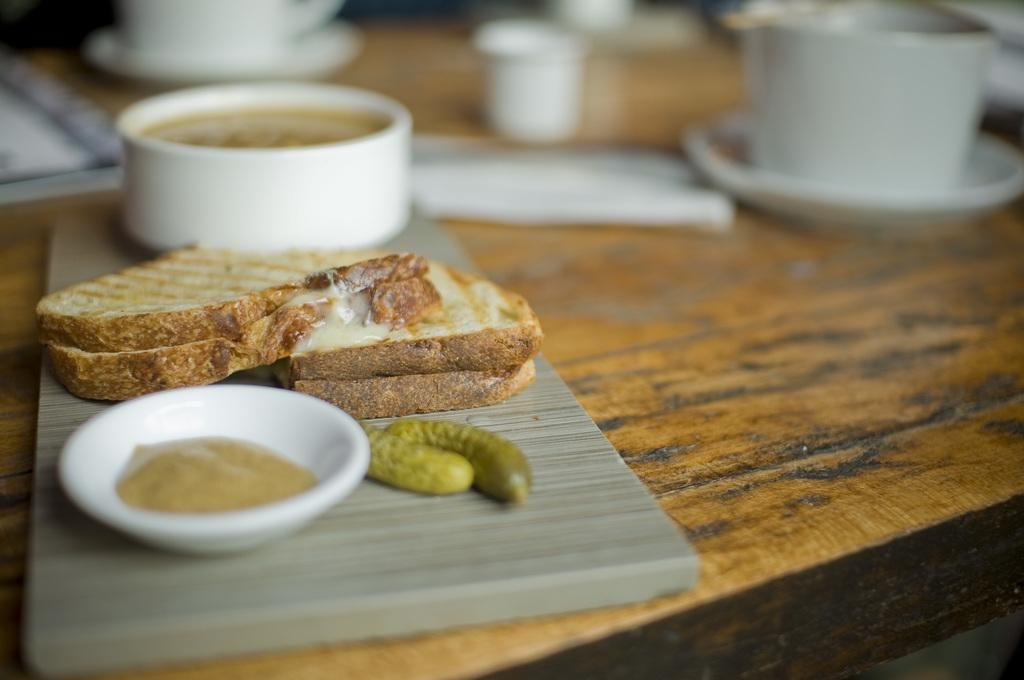What type of dishware is visible in the image? There is a cup with a saucer in the image. Are there any other types of dishware present? Yes, there are bowls in the image. What is the surface on which the dishware is placed? The items are placed on a wooden surface in the image. Who is the manager of the glove in the image? There is no glove present in the image, so there is no manager for a glove. 